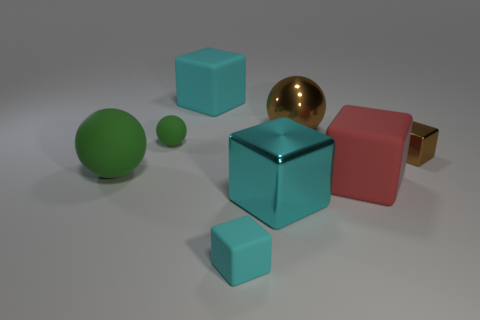How many cyan blocks must be subtracted to get 1 cyan blocks? 2 Subtract all gray cylinders. How many cyan blocks are left? 3 Subtract all red cubes. How many cubes are left? 4 Subtract all big metal cubes. How many cubes are left? 4 Subtract all purple cubes. Subtract all gray cylinders. How many cubes are left? 5 Add 1 cyan cubes. How many objects exist? 9 Subtract all cubes. How many objects are left? 3 Subtract all tiny objects. Subtract all small brown blocks. How many objects are left? 4 Add 1 matte blocks. How many matte blocks are left? 4 Add 2 big cubes. How many big cubes exist? 5 